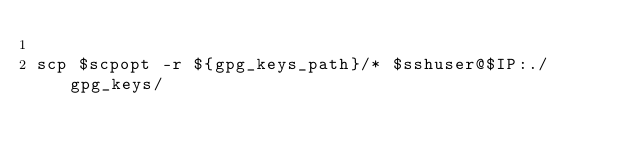<code> <loc_0><loc_0><loc_500><loc_500><_Bash_>
scp $scpopt -r ${gpg_keys_path}/* $sshuser@$IP:./gpg_keys/</code> 